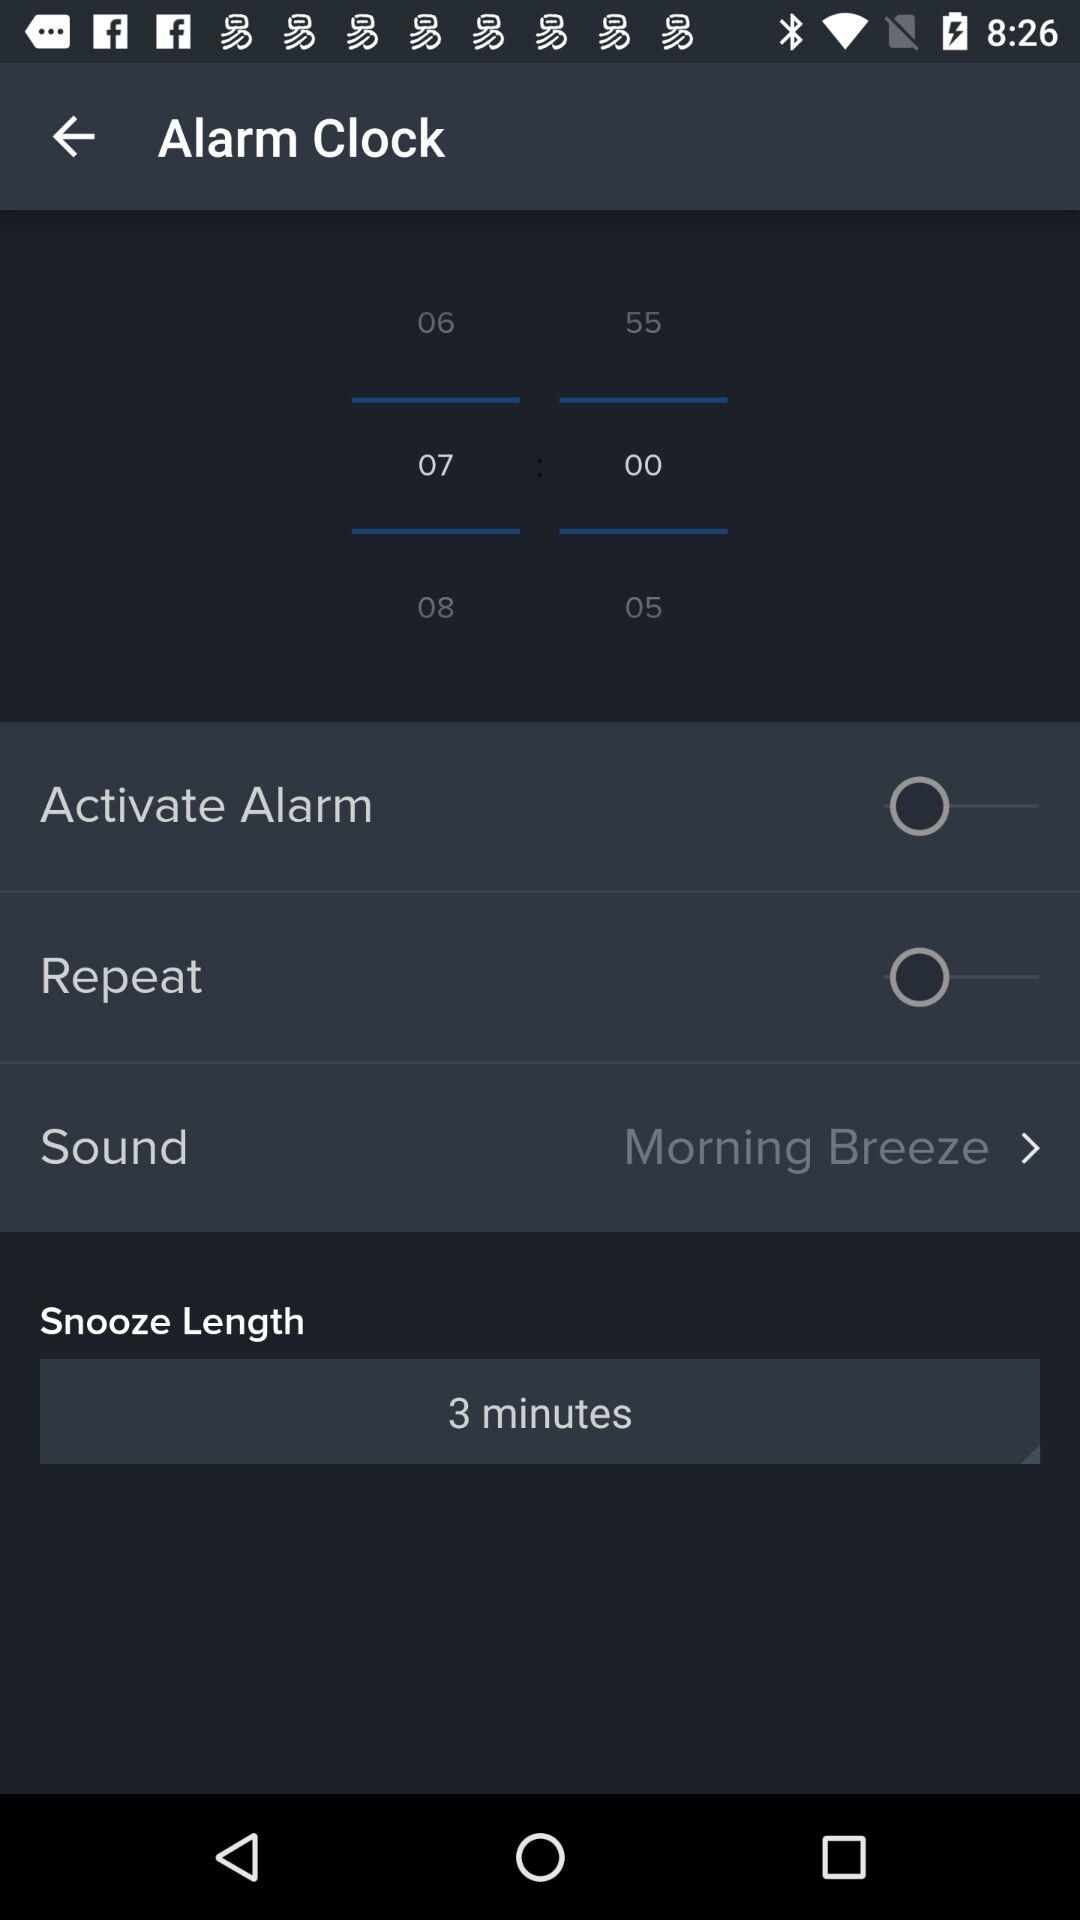What is the selected sound? The selected sound is Morning Breeze. 